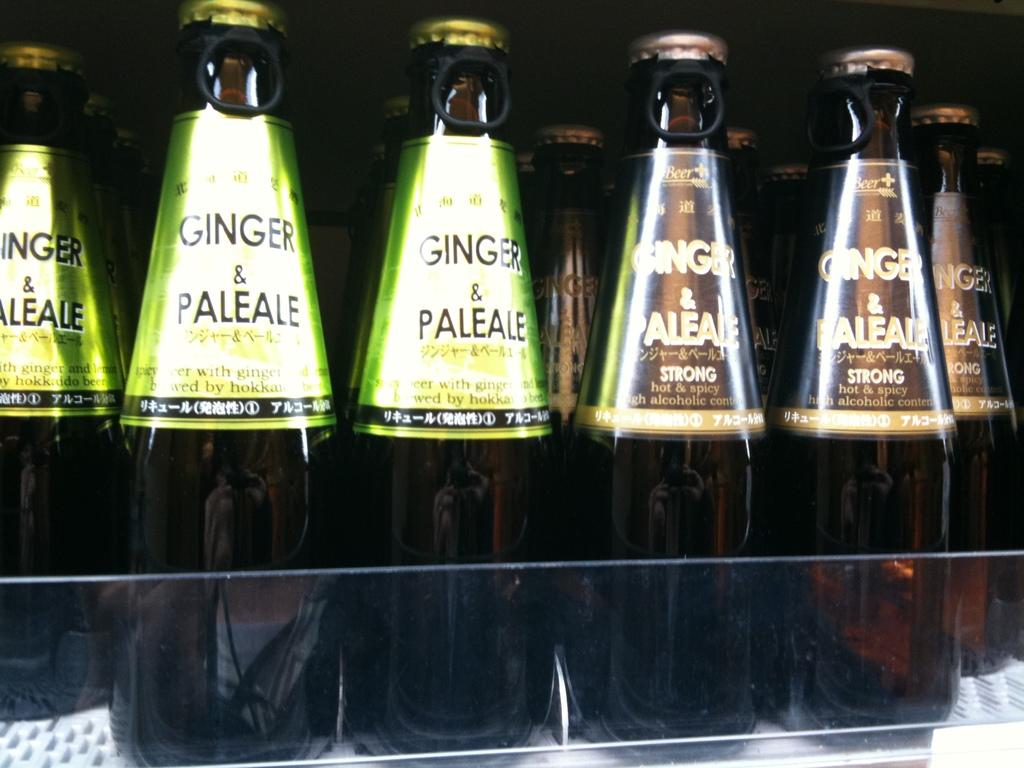What type of beverage is in the bottle with the brown label?
Ensure brevity in your answer.  Pale ale. 